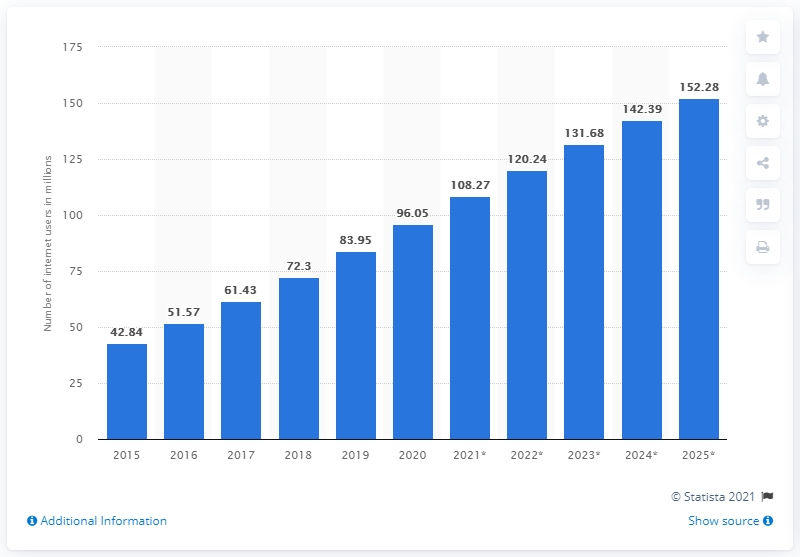Point out several critical features in this image. According to projections, the number of internet users in Nigeria is expected to reach 131.68 million by 2023. 